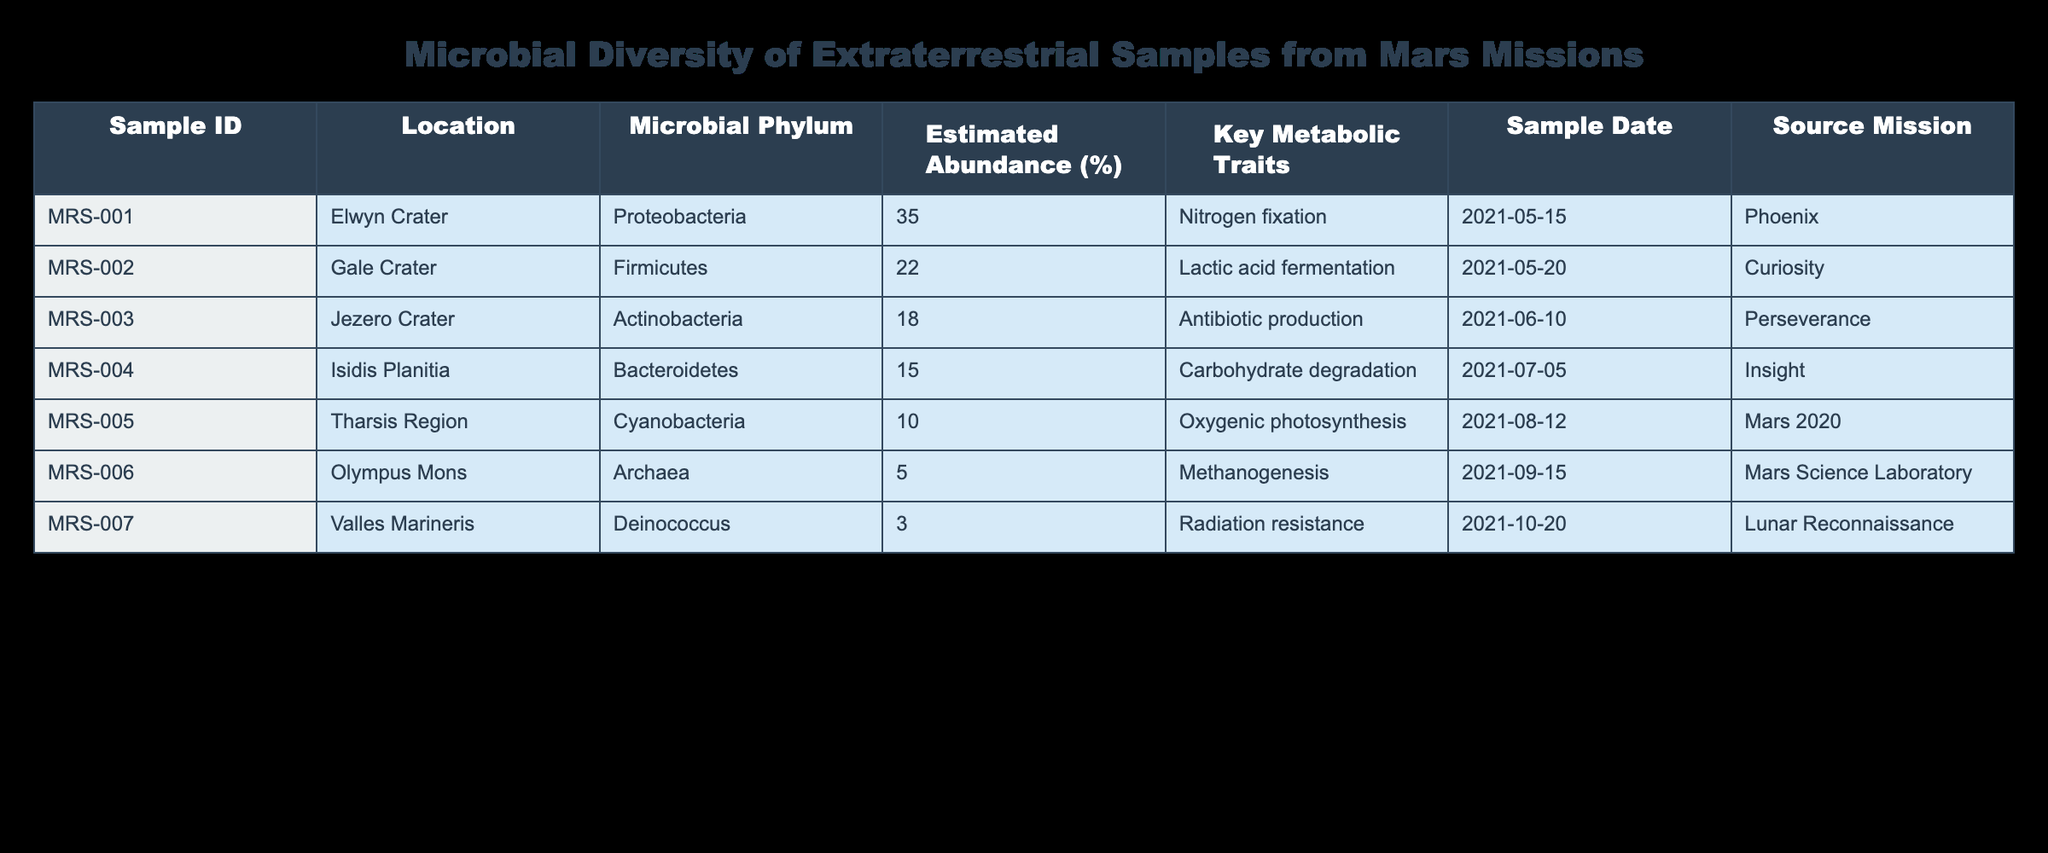What is the most abundant microbial phylum found in the samples? The table lists the estimated abundance percentages for each microbial phylum. By reviewing the values, Proteobacteria has the highest estimate at 35%.
Answer: 35% Which location has the least microbial abundance among the samples? By comparing the estimated abundance percentages provided for each location, Valles Marineris has the least abundance, which is 3%.
Answer: 3% How many samples were collected from Gale Crater? The table provides one entry for Gale Crater, which corresponds to Sample ID MRS-002. Therefore, there is one sample from this location.
Answer: 1 What is the average estimated abundance of Actinobacteria and Cyanobacteria? The estimated abundance for Actinobacteria is 18% and for Cyanobacteria is 10%. To find the average, add these two values (18 + 10 = 28) and divide by 2, giving an average of 14%.
Answer: 14% Is there any sample from Olympus Mons that exhibits nitrogen fixation? According to the table, the sample from Olympus Mons (MRS-006) has a metabolic trait of methanogenesis and does not exhibit nitrogen fixation. Therefore, the answer is no.
Answer: No Which sample has the highest estimated abundance and what are its key metabolic traits? The sample with the highest abundance is MRS-001 from Elwyn Crater, which has an estimated abundance of 35%. Its key metabolic traits include nitrogen fixation.
Answer: MRS-001: nitrogen fixation What percentage of the samples are from the Curiosity mission? There are a total of 7 samples listed, and only one sample (MRS-002) is from the Curiosity mission. Thus, the percentage is (1/7) * 100 = 14.29%, which can be rounded to 14%.
Answer: 14% How many different metabolic traits are represented in the table? By reviewing the metabolic traits for each of the 7 samples, there are six unique traits: nitrogen fixation, lactic acid fermentation, antibiotic production, carbohydrate degradation, oxygenic photosynthesis, methanogenesis, and radiation resistance.
Answer: 6 If we combine the estimated abundance of Archaea and Deinococcus, what is the total? The estimated abundance for Archaea is 5% and for Deinococcus is 3%. Adding these together (5 + 3 = 8), the combined estimated abundance is 8%.
Answer: 8% 